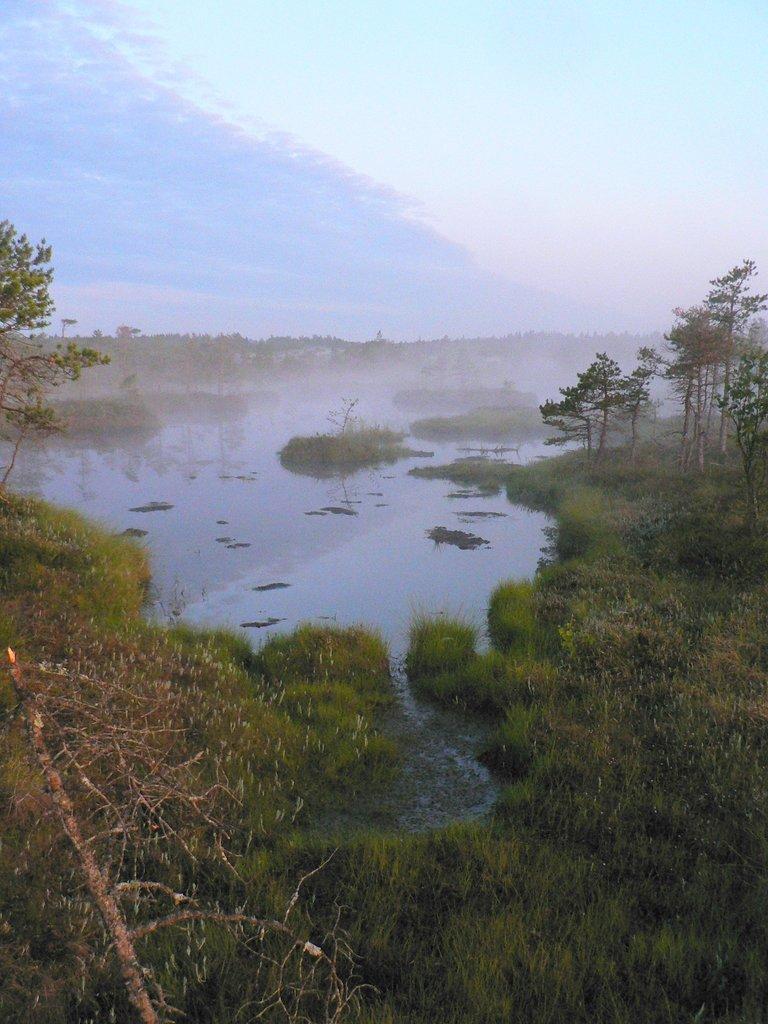How would you summarize this image in a sentence or two? There are plants and trees. Also there is water. In the back there is sky. 